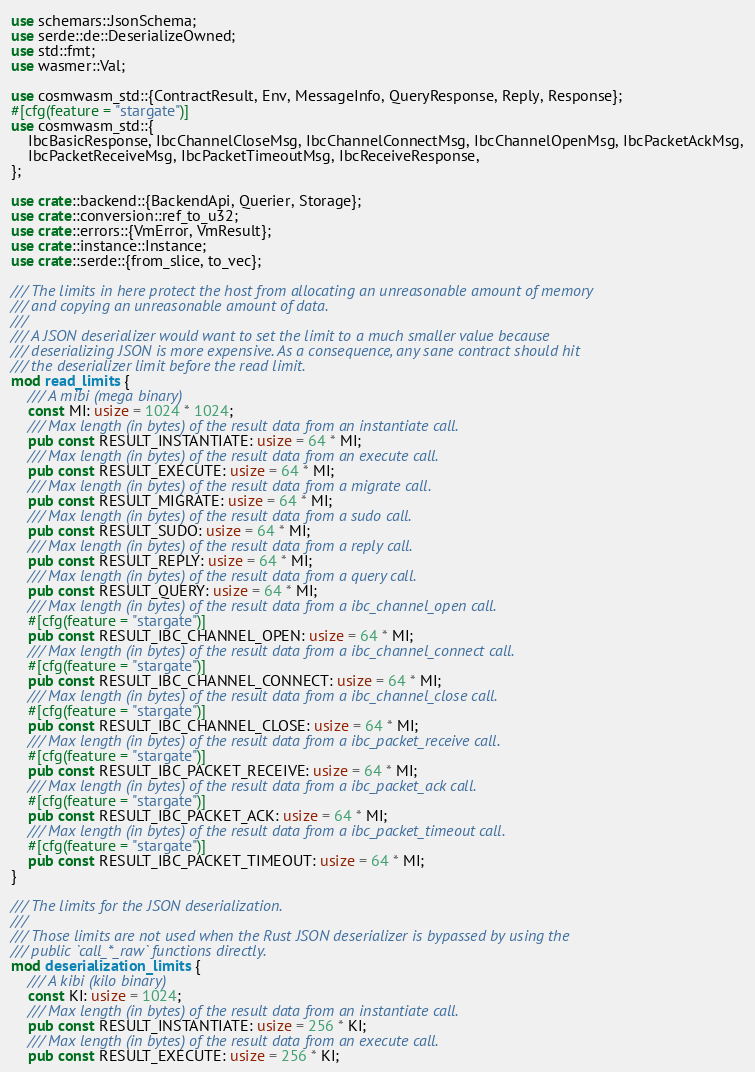Convert code to text. <code><loc_0><loc_0><loc_500><loc_500><_Rust_>use schemars::JsonSchema;
use serde::de::DeserializeOwned;
use std::fmt;
use wasmer::Val;

use cosmwasm_std::{ContractResult, Env, MessageInfo, QueryResponse, Reply, Response};
#[cfg(feature = "stargate")]
use cosmwasm_std::{
    IbcBasicResponse, IbcChannelCloseMsg, IbcChannelConnectMsg, IbcChannelOpenMsg, IbcPacketAckMsg,
    IbcPacketReceiveMsg, IbcPacketTimeoutMsg, IbcReceiveResponse,
};

use crate::backend::{BackendApi, Querier, Storage};
use crate::conversion::ref_to_u32;
use crate::errors::{VmError, VmResult};
use crate::instance::Instance;
use crate::serde::{from_slice, to_vec};

/// The limits in here protect the host from allocating an unreasonable amount of memory
/// and copying an unreasonable amount of data.
///
/// A JSON deserializer would want to set the limit to a much smaller value because
/// deserializing JSON is more expensive. As a consequence, any sane contract should hit
/// the deserializer limit before the read limit.
mod read_limits {
    /// A mibi (mega binary)
    const MI: usize = 1024 * 1024;
    /// Max length (in bytes) of the result data from an instantiate call.
    pub const RESULT_INSTANTIATE: usize = 64 * MI;
    /// Max length (in bytes) of the result data from an execute call.
    pub const RESULT_EXECUTE: usize = 64 * MI;
    /// Max length (in bytes) of the result data from a migrate call.
    pub const RESULT_MIGRATE: usize = 64 * MI;
    /// Max length (in bytes) of the result data from a sudo call.
    pub const RESULT_SUDO: usize = 64 * MI;
    /// Max length (in bytes) of the result data from a reply call.
    pub const RESULT_REPLY: usize = 64 * MI;
    /// Max length (in bytes) of the result data from a query call.
    pub const RESULT_QUERY: usize = 64 * MI;
    /// Max length (in bytes) of the result data from a ibc_channel_open call.
    #[cfg(feature = "stargate")]
    pub const RESULT_IBC_CHANNEL_OPEN: usize = 64 * MI;
    /// Max length (in bytes) of the result data from a ibc_channel_connect call.
    #[cfg(feature = "stargate")]
    pub const RESULT_IBC_CHANNEL_CONNECT: usize = 64 * MI;
    /// Max length (in bytes) of the result data from a ibc_channel_close call.
    #[cfg(feature = "stargate")]
    pub const RESULT_IBC_CHANNEL_CLOSE: usize = 64 * MI;
    /// Max length (in bytes) of the result data from a ibc_packet_receive call.
    #[cfg(feature = "stargate")]
    pub const RESULT_IBC_PACKET_RECEIVE: usize = 64 * MI;
    /// Max length (in bytes) of the result data from a ibc_packet_ack call.
    #[cfg(feature = "stargate")]
    pub const RESULT_IBC_PACKET_ACK: usize = 64 * MI;
    /// Max length (in bytes) of the result data from a ibc_packet_timeout call.
    #[cfg(feature = "stargate")]
    pub const RESULT_IBC_PACKET_TIMEOUT: usize = 64 * MI;
}

/// The limits for the JSON deserialization.
///
/// Those limits are not used when the Rust JSON deserializer is bypassed by using the
/// public `call_*_raw` functions directly.
mod deserialization_limits {
    /// A kibi (kilo binary)
    const KI: usize = 1024;
    /// Max length (in bytes) of the result data from an instantiate call.
    pub const RESULT_INSTANTIATE: usize = 256 * KI;
    /// Max length (in bytes) of the result data from an execute call.
    pub const RESULT_EXECUTE: usize = 256 * KI;</code> 